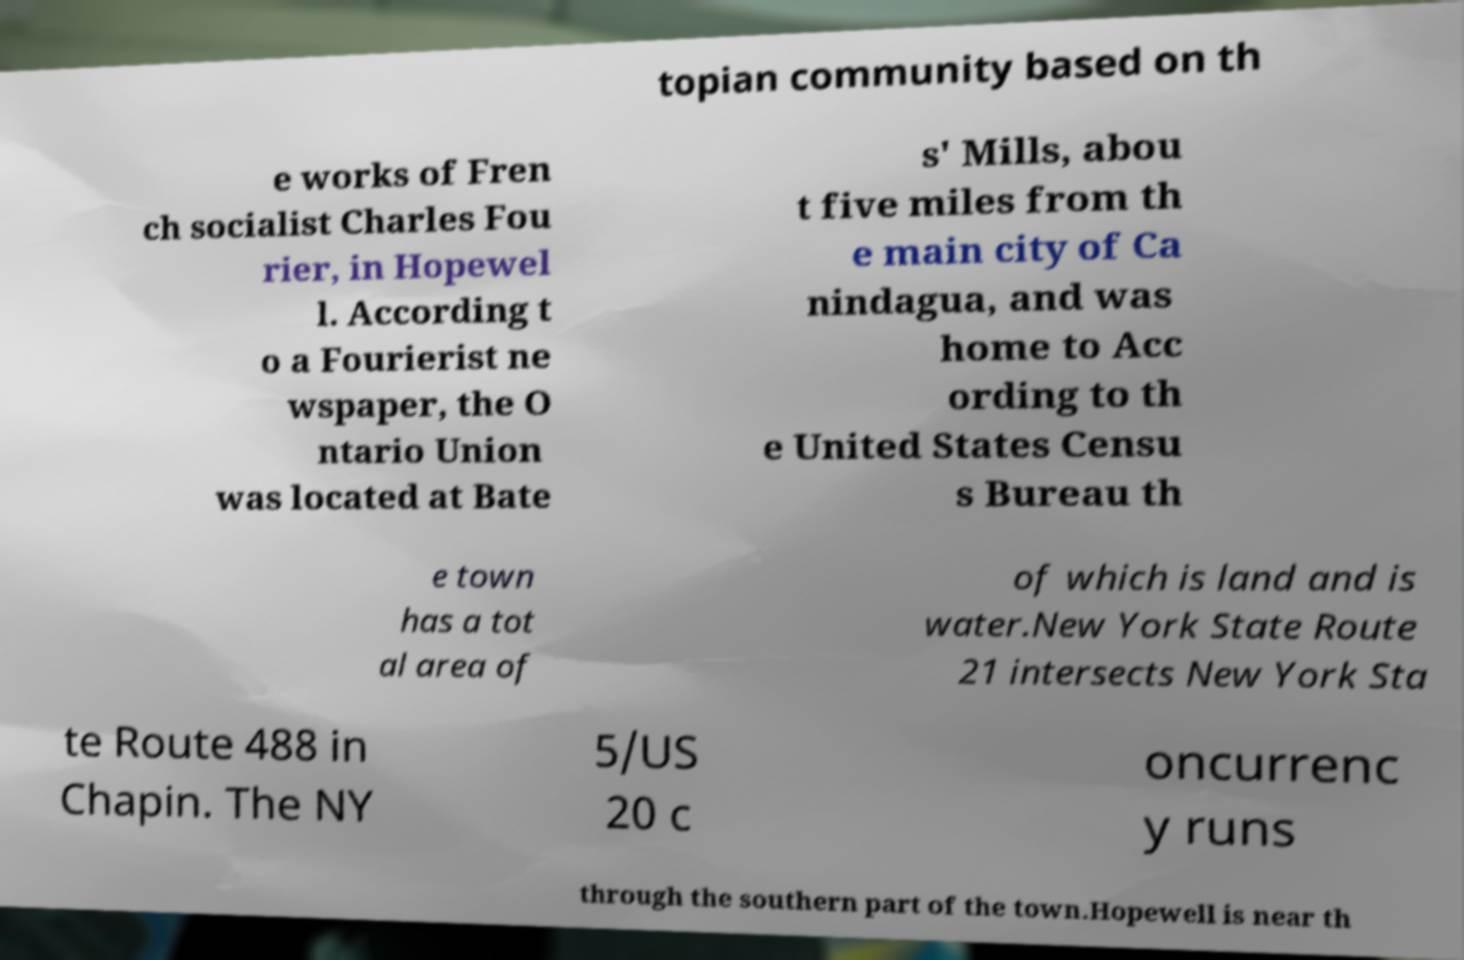There's text embedded in this image that I need extracted. Can you transcribe it verbatim? topian community based on th e works of Fren ch socialist Charles Fou rier, in Hopewel l. According t o a Fourierist ne wspaper, the O ntario Union was located at Bate s' Mills, abou t five miles from th e main city of Ca nindagua, and was home to Acc ording to th e United States Censu s Bureau th e town has a tot al area of of which is land and is water.New York State Route 21 intersects New York Sta te Route 488 in Chapin. The NY 5/US 20 c oncurrenc y runs through the southern part of the town.Hopewell is near th 